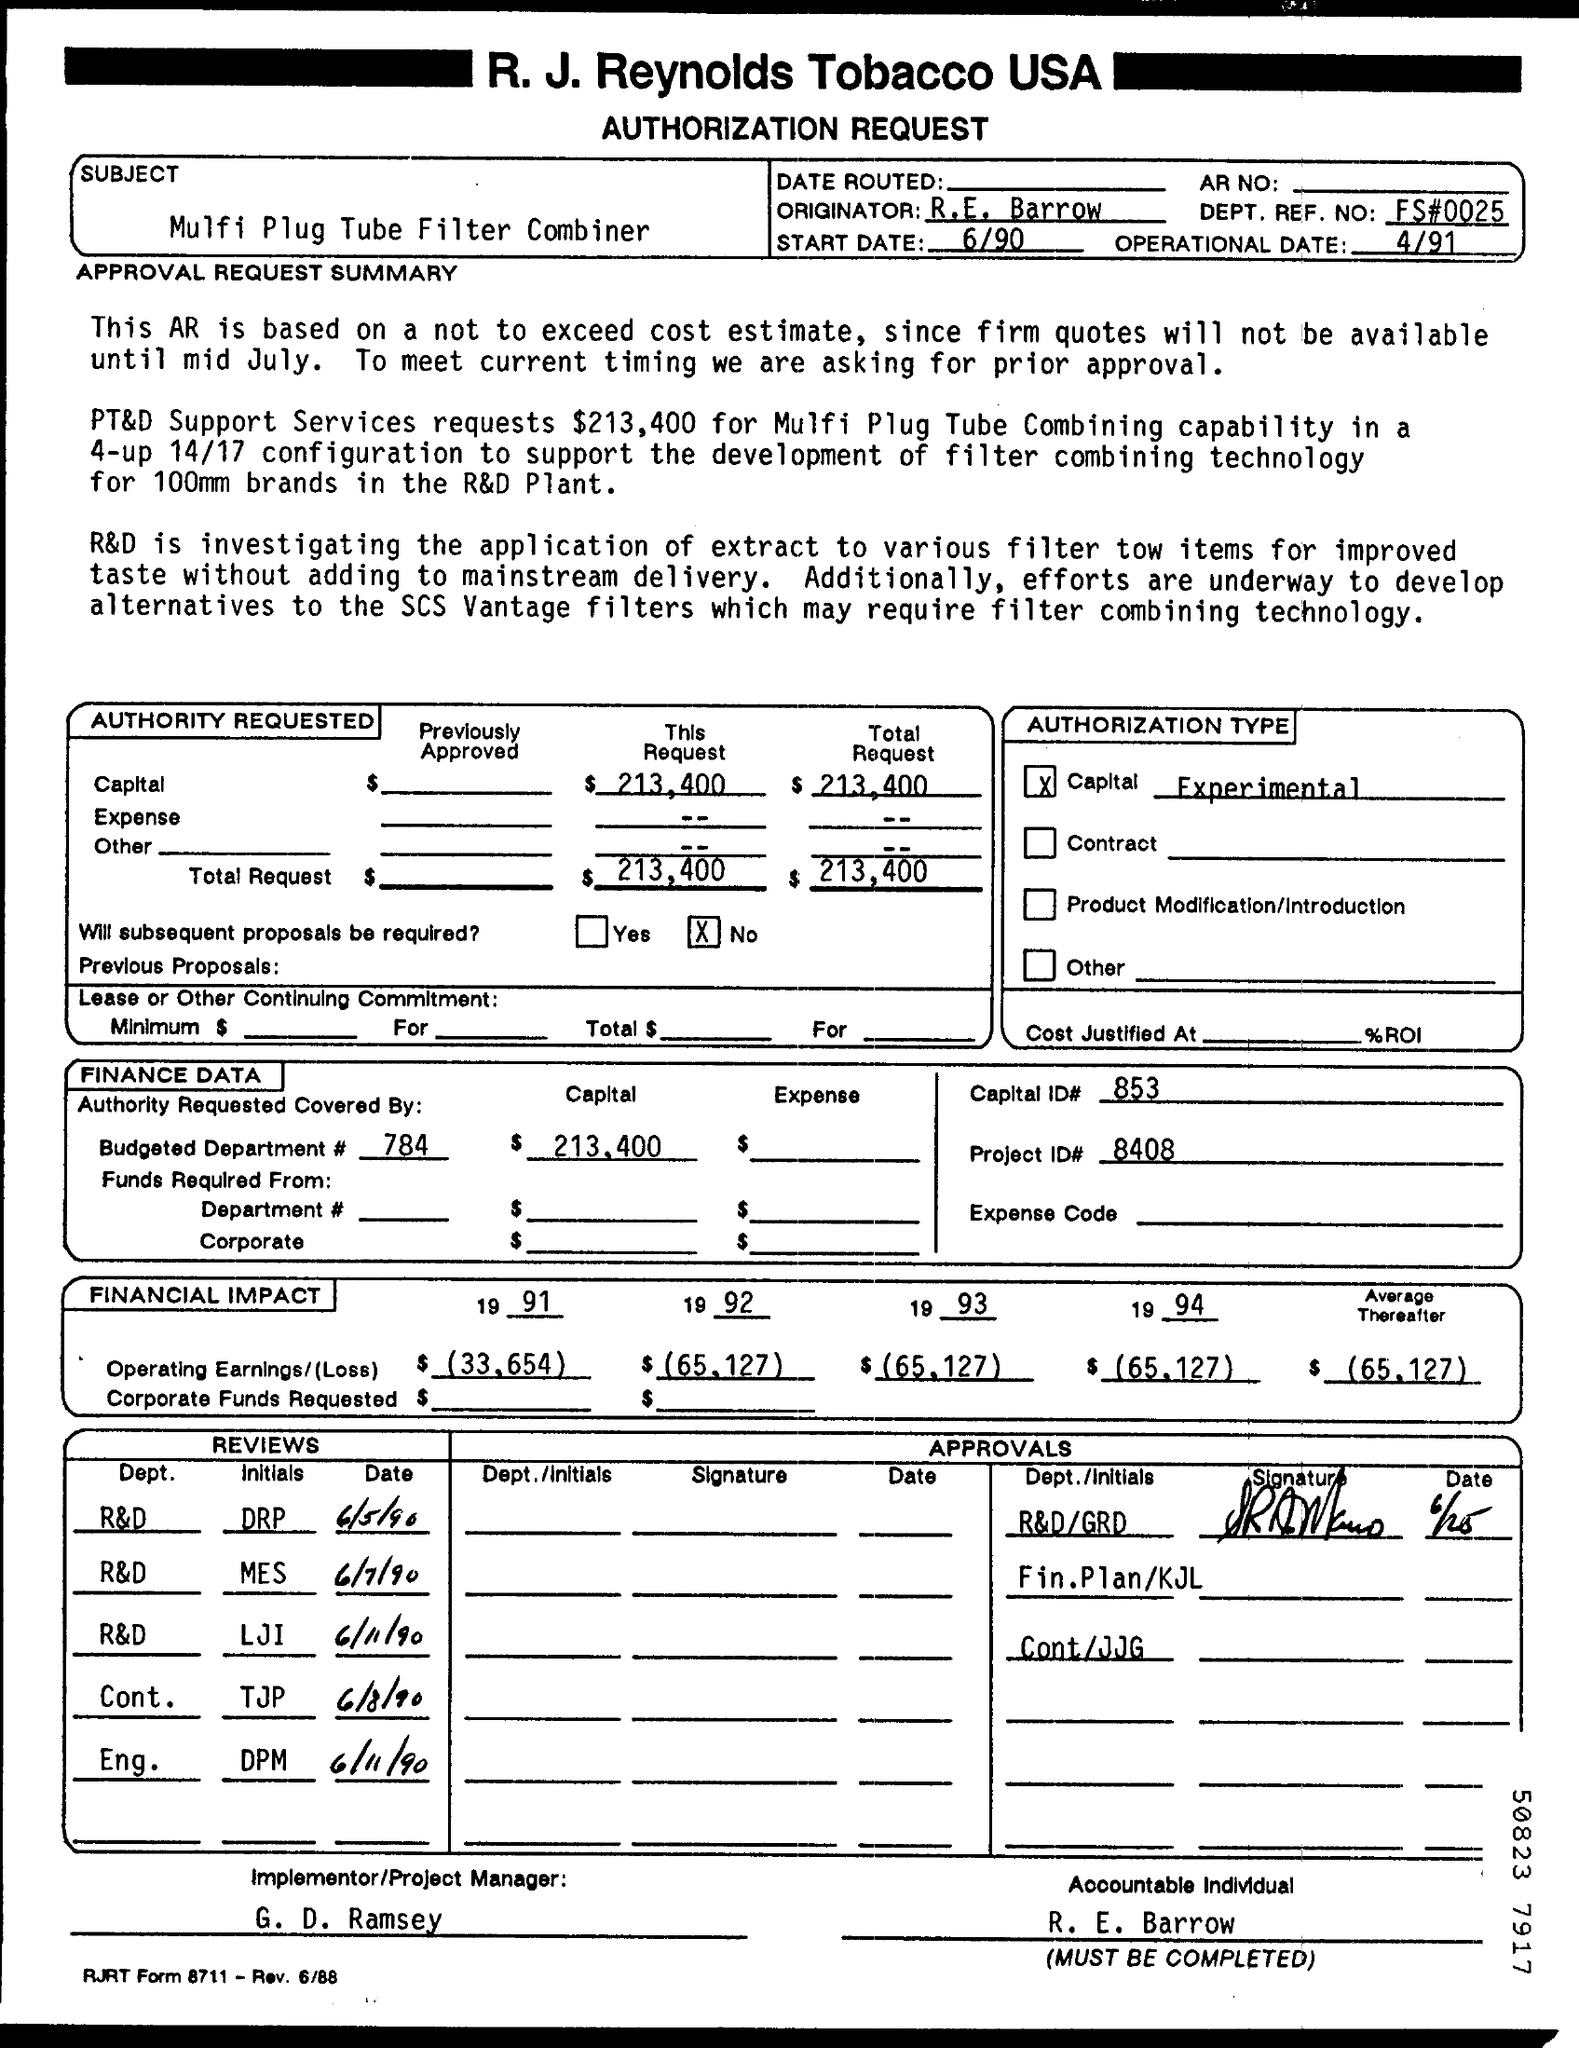Point out several critical features in this image. It is known that the Implementer/Project Manager is G. D. Ramsey. The DEPT. REF. NO of this Request form is unknown. This is a Request form with a reference number of FS#0025.. The subject of the request form is the MULFI PLUG TUBE FILTER COMBINER. 